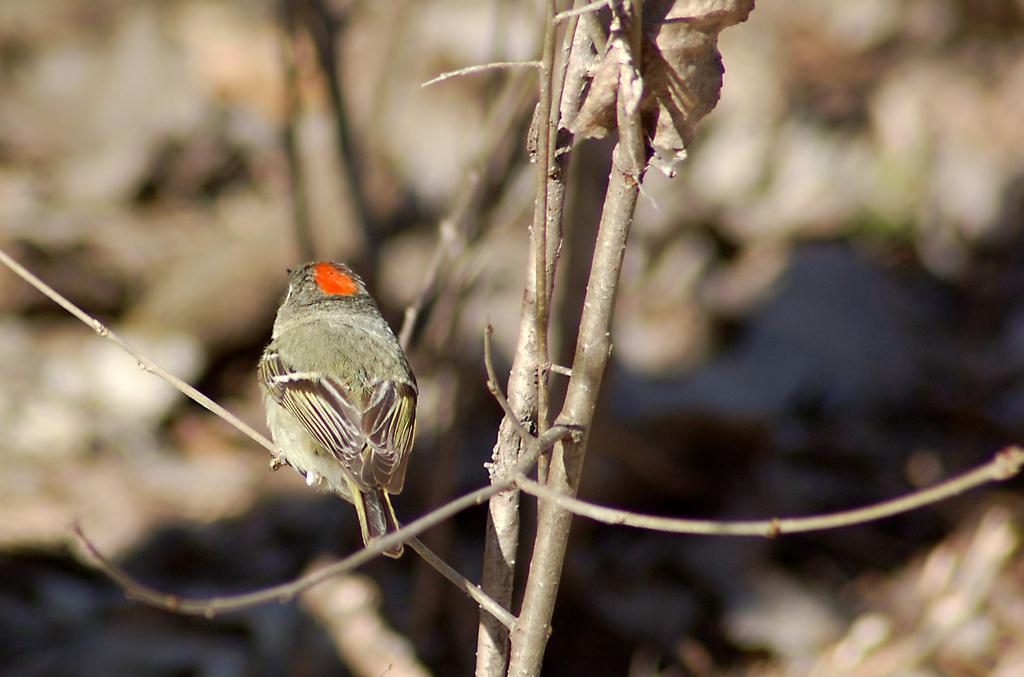What type of animal is present in the image? There is a bird in the image. What other living organism can be seen in the image? There is a plant in the image. Can you describe the background of the image? The background of the image is blurred. What type of drink is the bird holding in the image? There is no drink present in the image; the bird is not holding anything. 